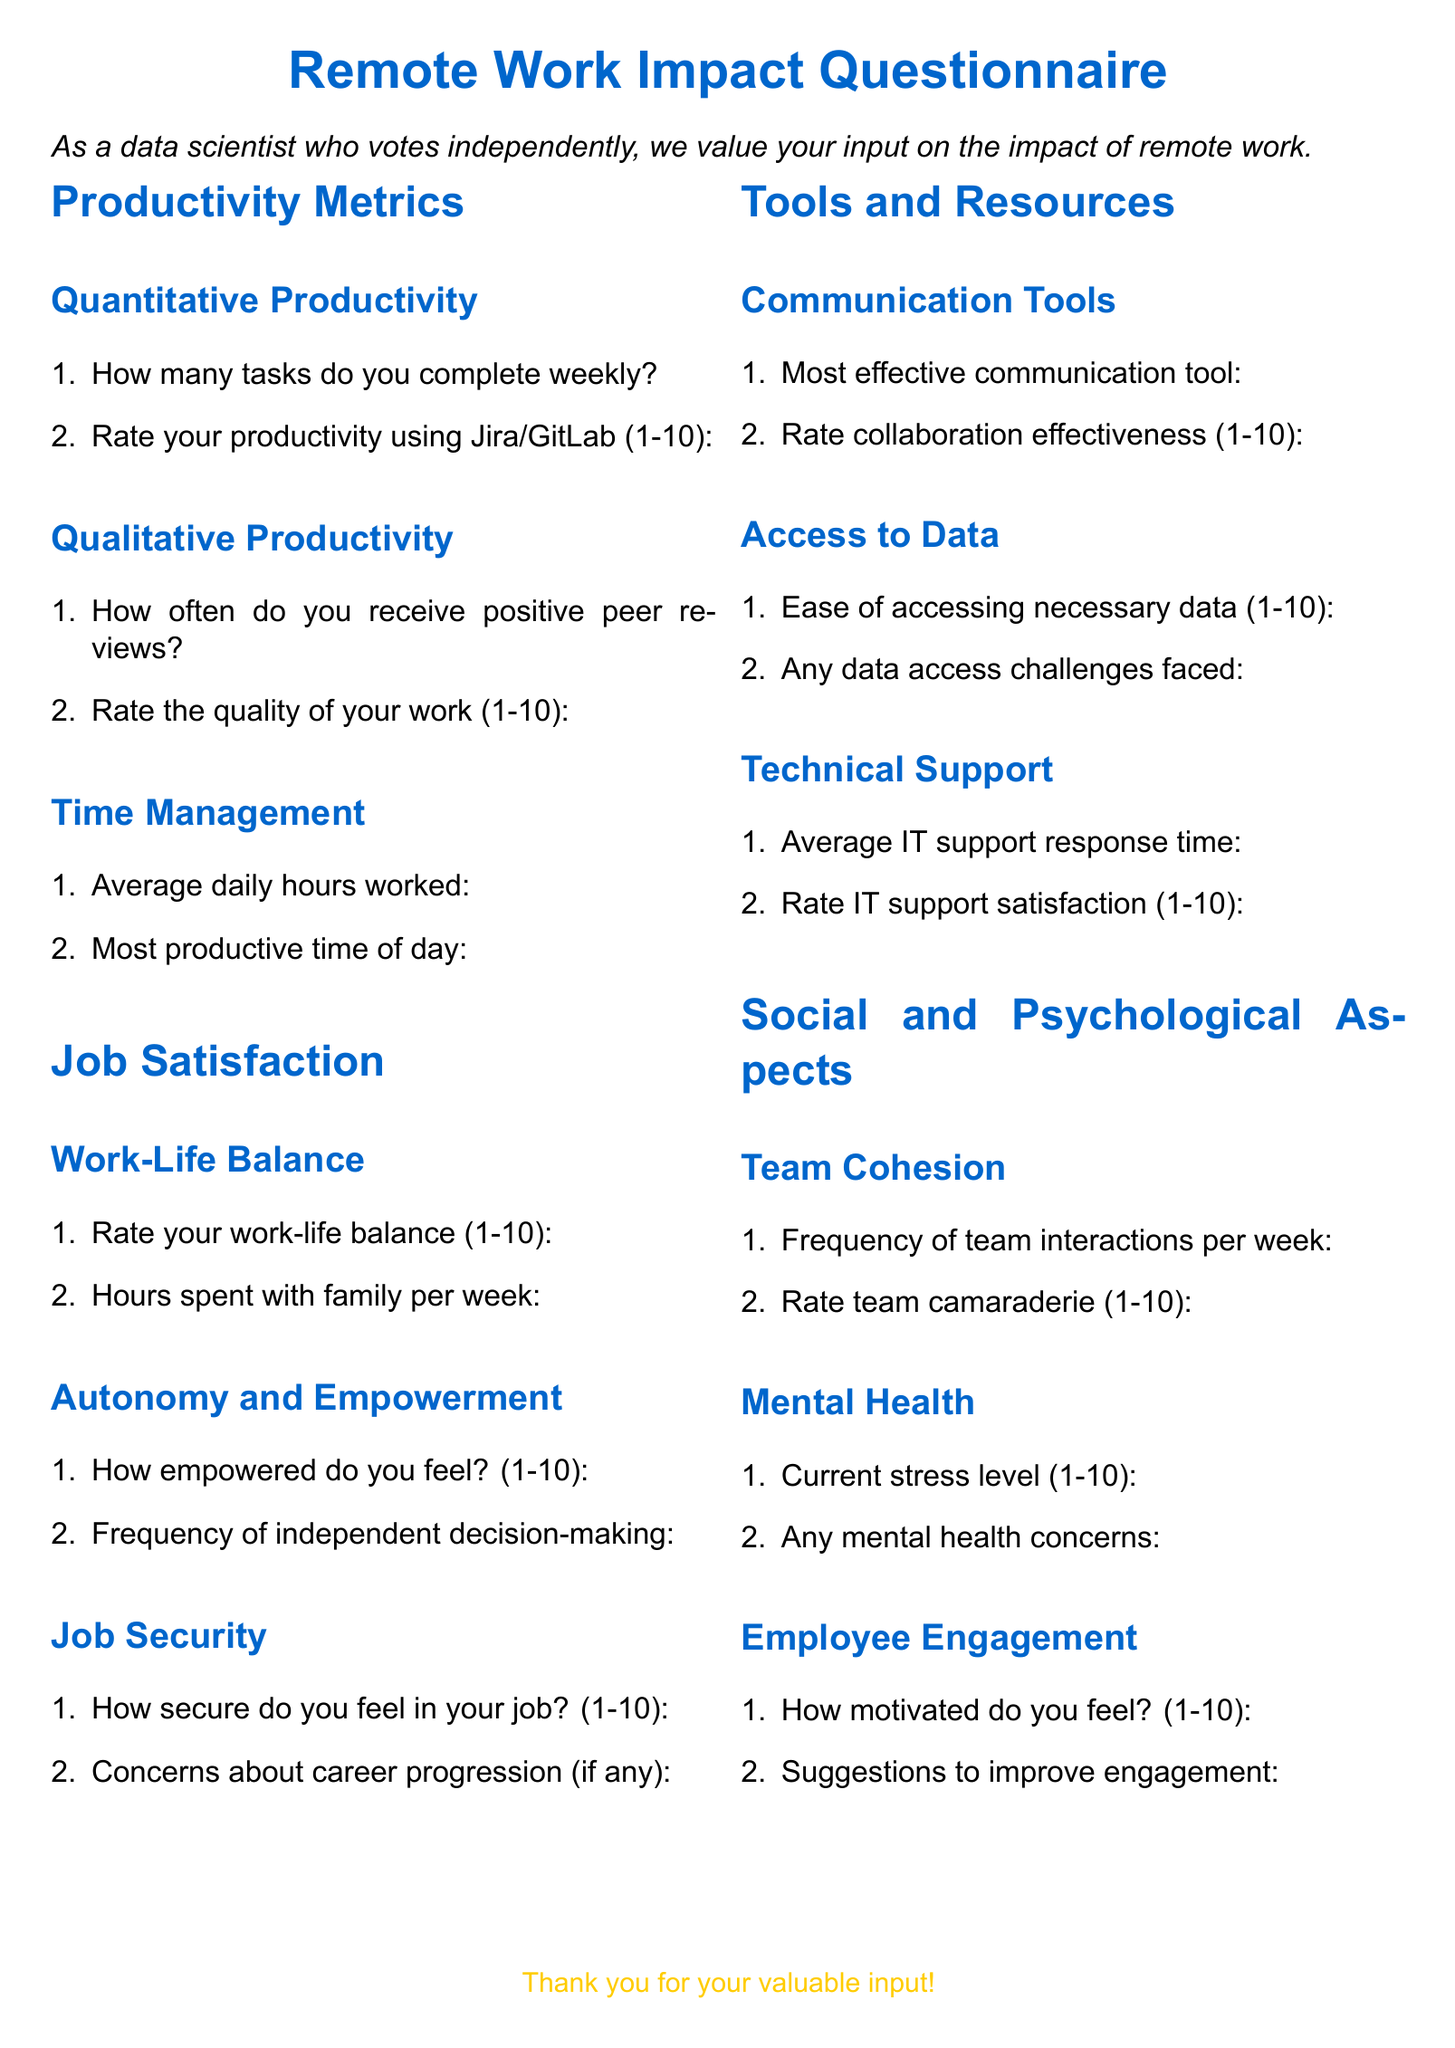What is the title of the document? The title is presented at the beginning of the document, clearly stating its purpose.
Answer: Remote Work Impact Questionnaire How many sections are in the questionnaire? The document is divided into several clear sections, each addressing a specific area of impact.
Answer: 4 What is the rating scale used for productivity? The document specifies a numerical scale for various ratings, indicating a common method for assessment.
Answer: 1-10 What is included in the "Job Security" section? This section comprises two items that assess feelings of security and concerns related to career progression.
Answer: How secure do you feel in your job? and Concerns about career progression (if any) What is the first question in the "Qualitative Productivity" section? The document outlines the sequence of questions in this section, starting with an inquiry on peer feedback.
Answer: How often do you receive positive peer reviews? Rate team camaraderie is asked in which section? This question is part of assessing team dynamics and social relationships in the workplace.
Answer: Social and Psychological Aspects How many questions are there in the "Time Management" subsection? The subsection focuses on two main inquiries regarding work hours and productivity timing.
Answer: 2 What does the document ask about mental health? The document encompasses queries related to stress and any concerns about mental health.
Answer: Current stress level and Any mental health concerns What is the color used for headings in the document? The document adopts a specific color for its section headings, contributing to its aesthetic design.
Answer: Main color (RGB: 0,102,204) 